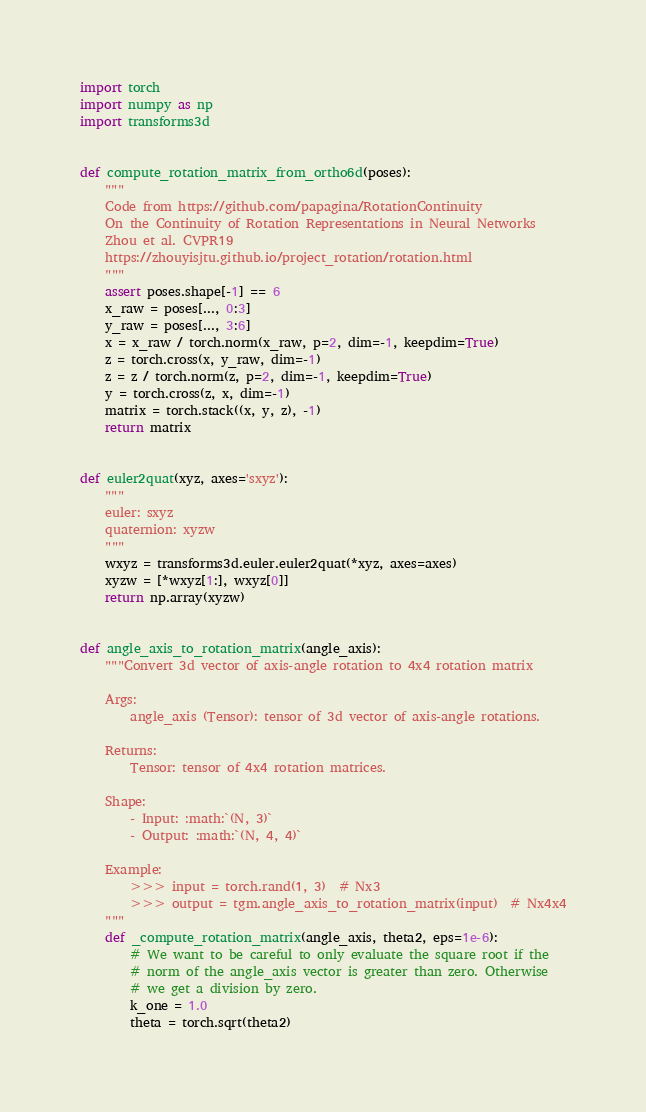Convert code to text. <code><loc_0><loc_0><loc_500><loc_500><_Python_>import torch
import numpy as np
import transforms3d


def compute_rotation_matrix_from_ortho6d(poses):
    """
    Code from https://github.com/papagina/RotationContinuity
    On the Continuity of Rotation Representations in Neural Networks
    Zhou et al. CVPR19
    https://zhouyisjtu.github.io/project_rotation/rotation.html
    """
    assert poses.shape[-1] == 6
    x_raw = poses[..., 0:3]
    y_raw = poses[..., 3:6]
    x = x_raw / torch.norm(x_raw, p=2, dim=-1, keepdim=True)
    z = torch.cross(x, y_raw, dim=-1)
    z = z / torch.norm(z, p=2, dim=-1, keepdim=True)
    y = torch.cross(z, x, dim=-1)
    matrix = torch.stack((x, y, z), -1)
    return matrix


def euler2quat(xyz, axes='sxyz'):
    """
    euler: sxyz
    quaternion: xyzw
    """
    wxyz = transforms3d.euler.euler2quat(*xyz, axes=axes)
    xyzw = [*wxyz[1:], wxyz[0]]
    return np.array(xyzw)


def angle_axis_to_rotation_matrix(angle_axis):
    """Convert 3d vector of axis-angle rotation to 4x4 rotation matrix

    Args:
        angle_axis (Tensor): tensor of 3d vector of axis-angle rotations.

    Returns:
        Tensor: tensor of 4x4 rotation matrices.

    Shape:
        - Input: :math:`(N, 3)`
        - Output: :math:`(N, 4, 4)`

    Example:
        >>> input = torch.rand(1, 3)  # Nx3
        >>> output = tgm.angle_axis_to_rotation_matrix(input)  # Nx4x4
    """
    def _compute_rotation_matrix(angle_axis, theta2, eps=1e-6):
        # We want to be careful to only evaluate the square root if the
        # norm of the angle_axis vector is greater than zero. Otherwise
        # we get a division by zero.
        k_one = 1.0
        theta = torch.sqrt(theta2)</code> 